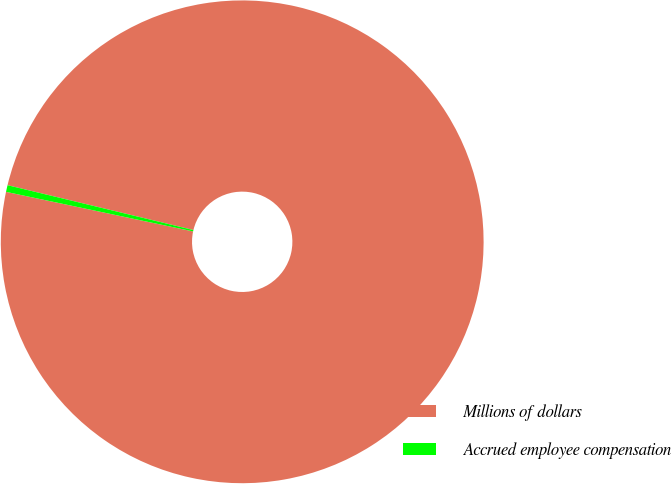Convert chart to OTSL. <chart><loc_0><loc_0><loc_500><loc_500><pie_chart><fcel>Millions of dollars<fcel>Accrued employee compensation<nl><fcel>99.55%<fcel>0.45%<nl></chart> 